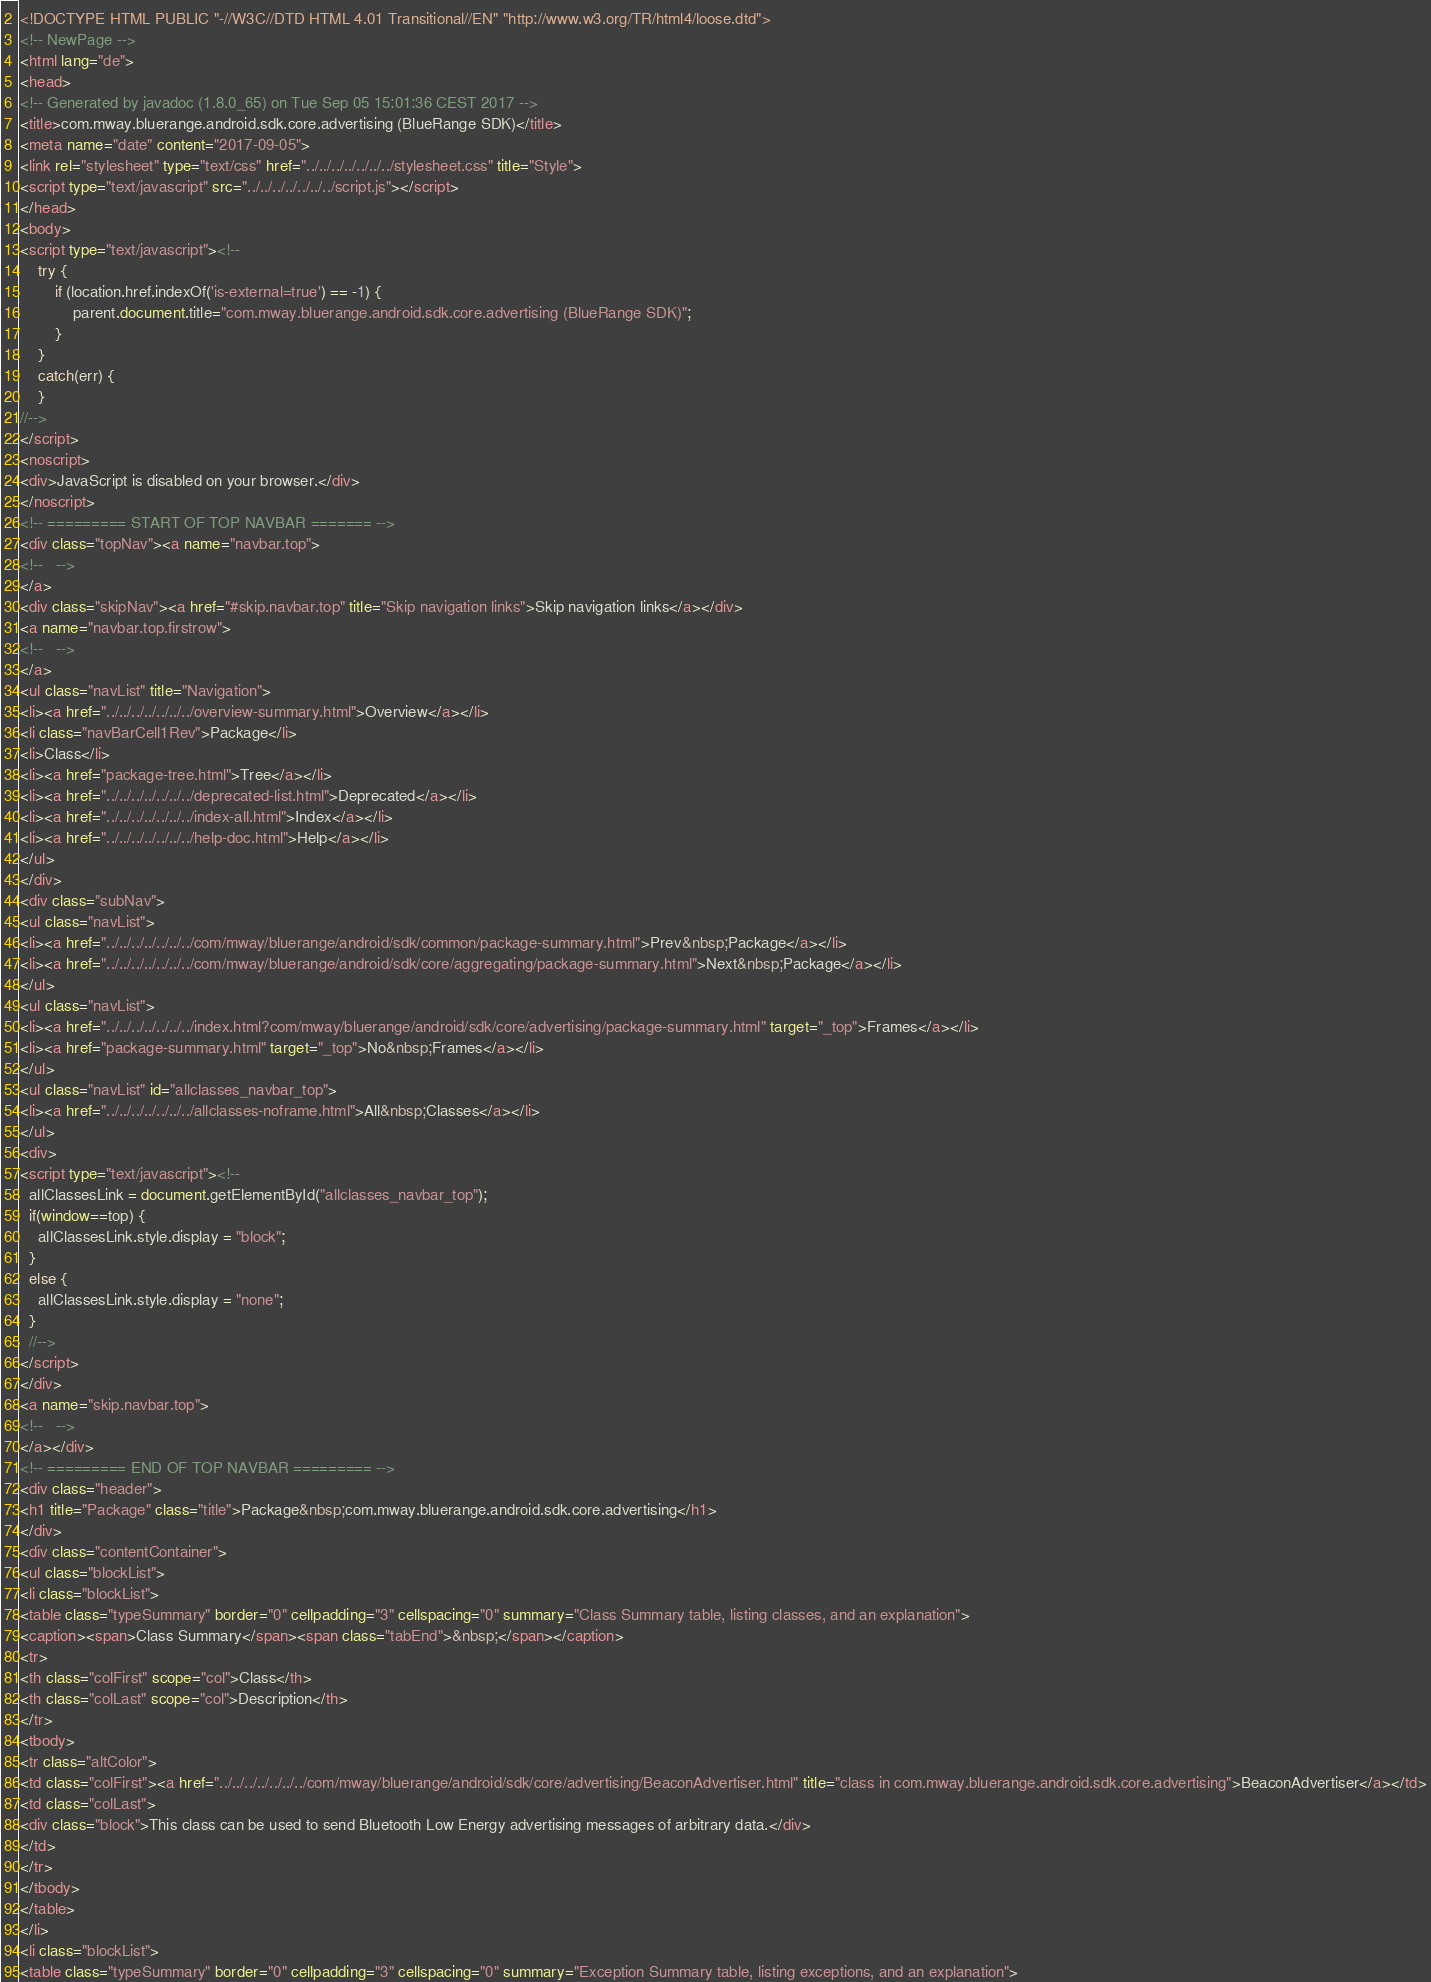<code> <loc_0><loc_0><loc_500><loc_500><_HTML_><!DOCTYPE HTML PUBLIC "-//W3C//DTD HTML 4.01 Transitional//EN" "http://www.w3.org/TR/html4/loose.dtd">
<!-- NewPage -->
<html lang="de">
<head>
<!-- Generated by javadoc (1.8.0_65) on Tue Sep 05 15:01:36 CEST 2017 -->
<title>com.mway.bluerange.android.sdk.core.advertising (BlueRange SDK)</title>
<meta name="date" content="2017-09-05">
<link rel="stylesheet" type="text/css" href="../../../../../../../stylesheet.css" title="Style">
<script type="text/javascript" src="../../../../../../../script.js"></script>
</head>
<body>
<script type="text/javascript"><!--
    try {
        if (location.href.indexOf('is-external=true') == -1) {
            parent.document.title="com.mway.bluerange.android.sdk.core.advertising (BlueRange SDK)";
        }
    }
    catch(err) {
    }
//-->
</script>
<noscript>
<div>JavaScript is disabled on your browser.</div>
</noscript>
<!-- ========= START OF TOP NAVBAR ======= -->
<div class="topNav"><a name="navbar.top">
<!--   -->
</a>
<div class="skipNav"><a href="#skip.navbar.top" title="Skip navigation links">Skip navigation links</a></div>
<a name="navbar.top.firstrow">
<!--   -->
</a>
<ul class="navList" title="Navigation">
<li><a href="../../../../../../../overview-summary.html">Overview</a></li>
<li class="navBarCell1Rev">Package</li>
<li>Class</li>
<li><a href="package-tree.html">Tree</a></li>
<li><a href="../../../../../../../deprecated-list.html">Deprecated</a></li>
<li><a href="../../../../../../../index-all.html">Index</a></li>
<li><a href="../../../../../../../help-doc.html">Help</a></li>
</ul>
</div>
<div class="subNav">
<ul class="navList">
<li><a href="../../../../../../../com/mway/bluerange/android/sdk/common/package-summary.html">Prev&nbsp;Package</a></li>
<li><a href="../../../../../../../com/mway/bluerange/android/sdk/core/aggregating/package-summary.html">Next&nbsp;Package</a></li>
</ul>
<ul class="navList">
<li><a href="../../../../../../../index.html?com/mway/bluerange/android/sdk/core/advertising/package-summary.html" target="_top">Frames</a></li>
<li><a href="package-summary.html" target="_top">No&nbsp;Frames</a></li>
</ul>
<ul class="navList" id="allclasses_navbar_top">
<li><a href="../../../../../../../allclasses-noframe.html">All&nbsp;Classes</a></li>
</ul>
<div>
<script type="text/javascript"><!--
  allClassesLink = document.getElementById("allclasses_navbar_top");
  if(window==top) {
    allClassesLink.style.display = "block";
  }
  else {
    allClassesLink.style.display = "none";
  }
  //-->
</script>
</div>
<a name="skip.navbar.top">
<!--   -->
</a></div>
<!-- ========= END OF TOP NAVBAR ========= -->
<div class="header">
<h1 title="Package" class="title">Package&nbsp;com.mway.bluerange.android.sdk.core.advertising</h1>
</div>
<div class="contentContainer">
<ul class="blockList">
<li class="blockList">
<table class="typeSummary" border="0" cellpadding="3" cellspacing="0" summary="Class Summary table, listing classes, and an explanation">
<caption><span>Class Summary</span><span class="tabEnd">&nbsp;</span></caption>
<tr>
<th class="colFirst" scope="col">Class</th>
<th class="colLast" scope="col">Description</th>
</tr>
<tbody>
<tr class="altColor">
<td class="colFirst"><a href="../../../../../../../com/mway/bluerange/android/sdk/core/advertising/BeaconAdvertiser.html" title="class in com.mway.bluerange.android.sdk.core.advertising">BeaconAdvertiser</a></td>
<td class="colLast">
<div class="block">This class can be used to send Bluetooth Low Energy advertising messages of arbitrary data.</div>
</td>
</tr>
</tbody>
</table>
</li>
<li class="blockList">
<table class="typeSummary" border="0" cellpadding="3" cellspacing="0" summary="Exception Summary table, listing exceptions, and an explanation"></code> 